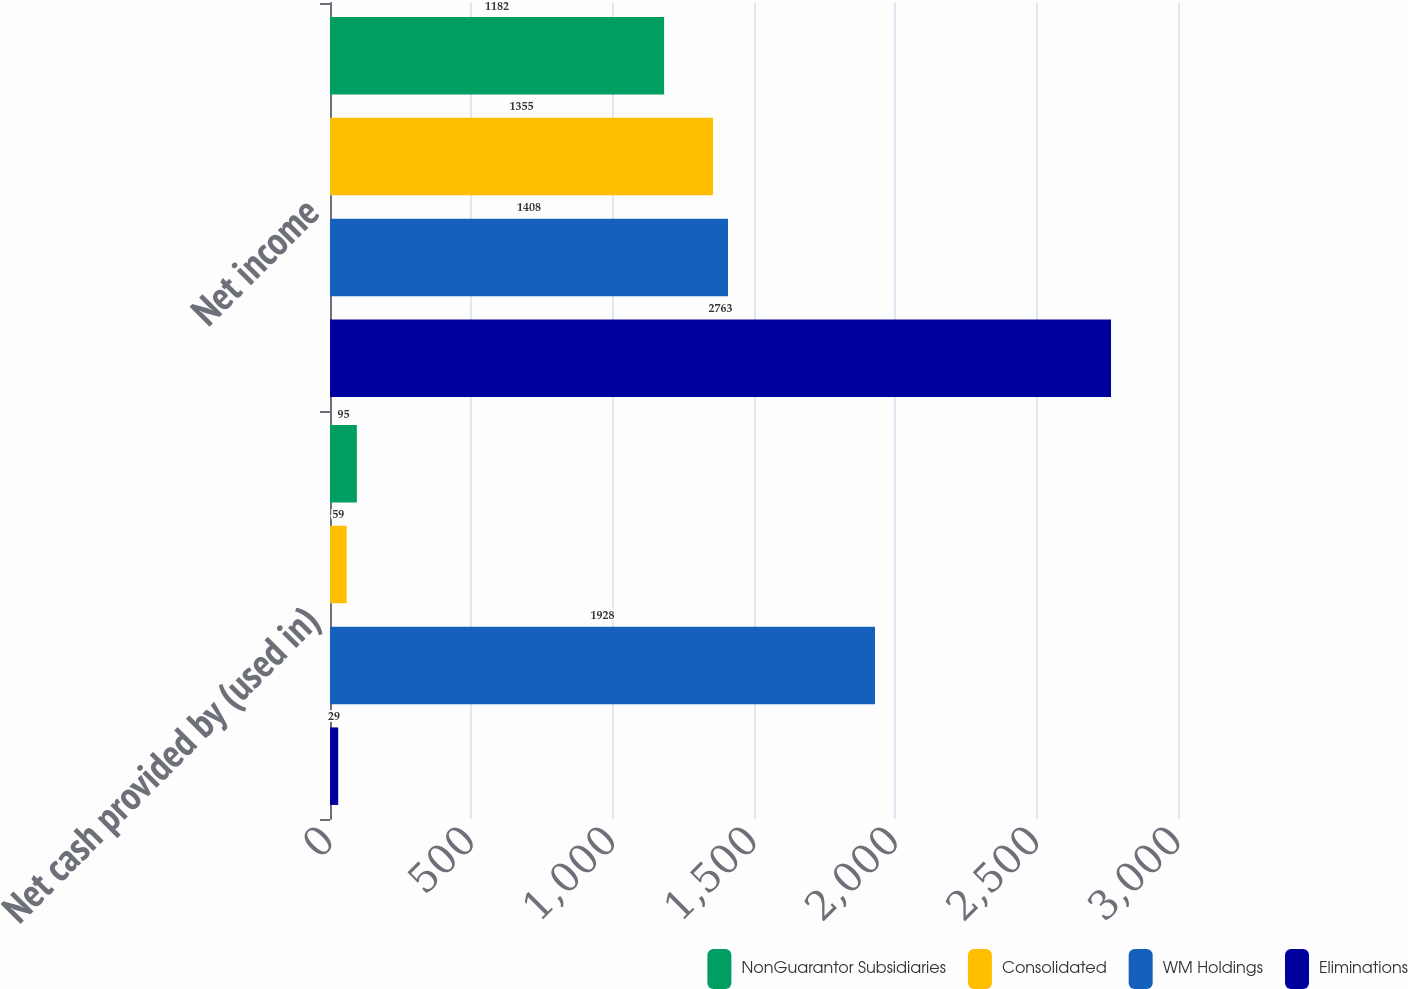Convert chart to OTSL. <chart><loc_0><loc_0><loc_500><loc_500><stacked_bar_chart><ecel><fcel>Net cash provided by (used in)<fcel>Net income<nl><fcel>NonGuarantor Subsidiaries<fcel>95<fcel>1182<nl><fcel>Consolidated<fcel>59<fcel>1355<nl><fcel>WM Holdings<fcel>1928<fcel>1408<nl><fcel>Eliminations<fcel>29<fcel>2763<nl></chart> 